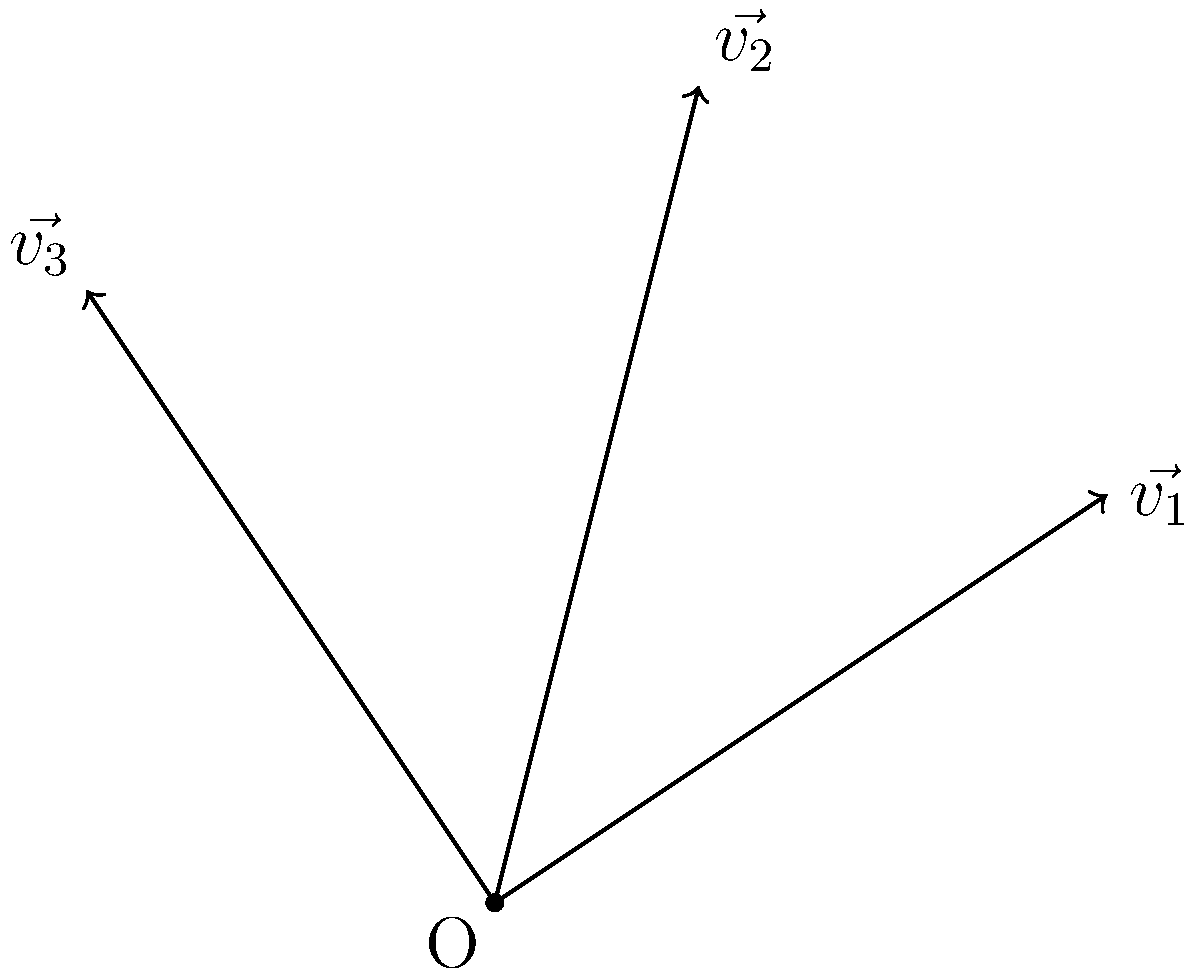At a Hillsong United concert, three groups of fans are moving in different directions. Their movements are represented by vectors $\vec{v_1}$, $\vec{v_2}$, and $\vec{v_3}$ as shown in the diagram. $\vec{v_1}$ has a magnitude of $\sqrt{13}$ m/s, $\vec{v_2}$ has a magnitude of $\sqrt{17}$ m/s, and $\vec{v_3}$ has a magnitude of $\sqrt{13}$ m/s. What is the magnitude of the resultant vector $\vec{v_R} = \vec{v_1} + \vec{v_2} + \vec{v_3}$? To find the magnitude of the resultant vector, we need to follow these steps:

1) First, we need to find the components of each vector:
   $\vec{v_1} = (3, 2)$
   $\vec{v_2} = (1, 4)$
   $\vec{v_3} = (-2, 3)$

2) Add the components of all vectors to get the resultant vector:
   $\vec{v_R} = \vec{v_1} + \vec{v_2} + \vec{v_3} = (3+1-2, 2+4+3) = (2, 9)$

3) Calculate the magnitude of the resultant vector using the Pythagorean theorem:
   $|\vec{v_R}| = \sqrt{x^2 + y^2} = \sqrt{2^2 + 9^2} = \sqrt{4 + 81} = \sqrt{85}$

Therefore, the magnitude of the resultant vector is $\sqrt{85}$ m/s.
Answer: $\sqrt{85}$ m/s 